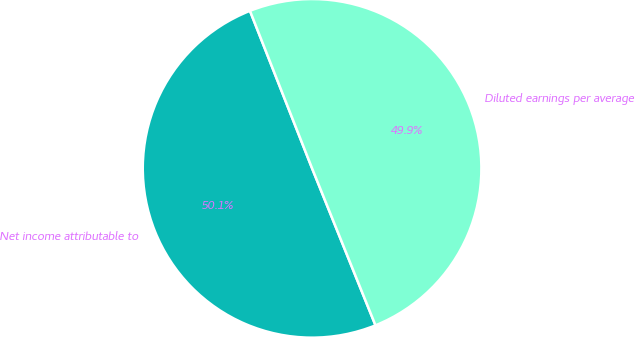Convert chart. <chart><loc_0><loc_0><loc_500><loc_500><pie_chart><fcel>Net income attributable to<fcel>Diluted earnings per average<nl><fcel>50.13%<fcel>49.87%<nl></chart> 